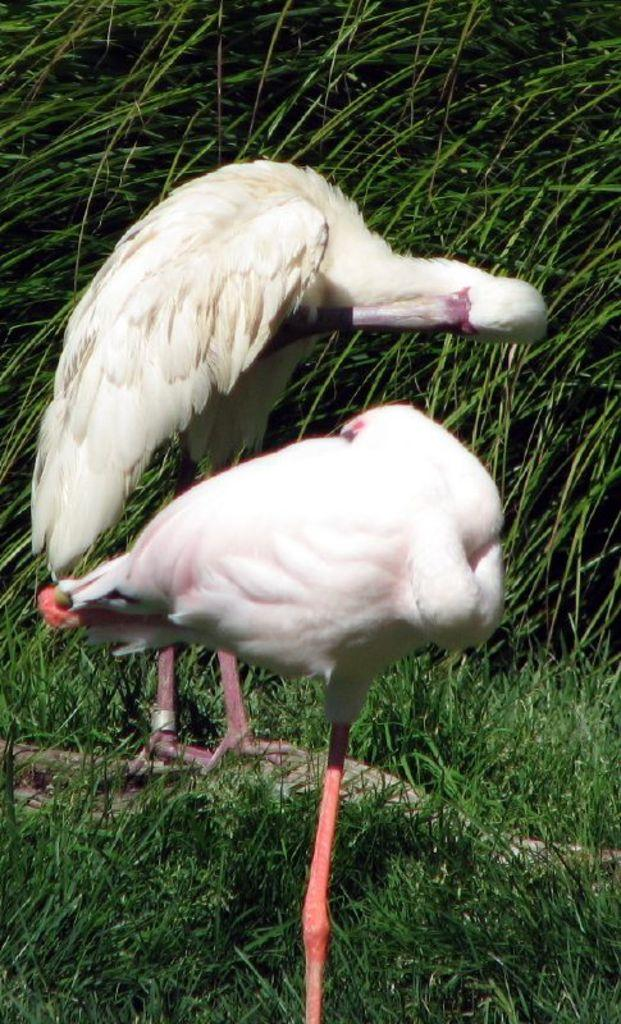What type of animals can be seen in the image? Birds can be seen in the image. What type of vegetation is visible in the image? There is grass and plants visible in the image. What is located in the center of the image? There is an object in the center of the image. How many houses are visible in the image? There are no houses present in the image. What type of stick can be seen being used by the birds in the image? There is no stick visible in the image, and the birds are not using any such object. 